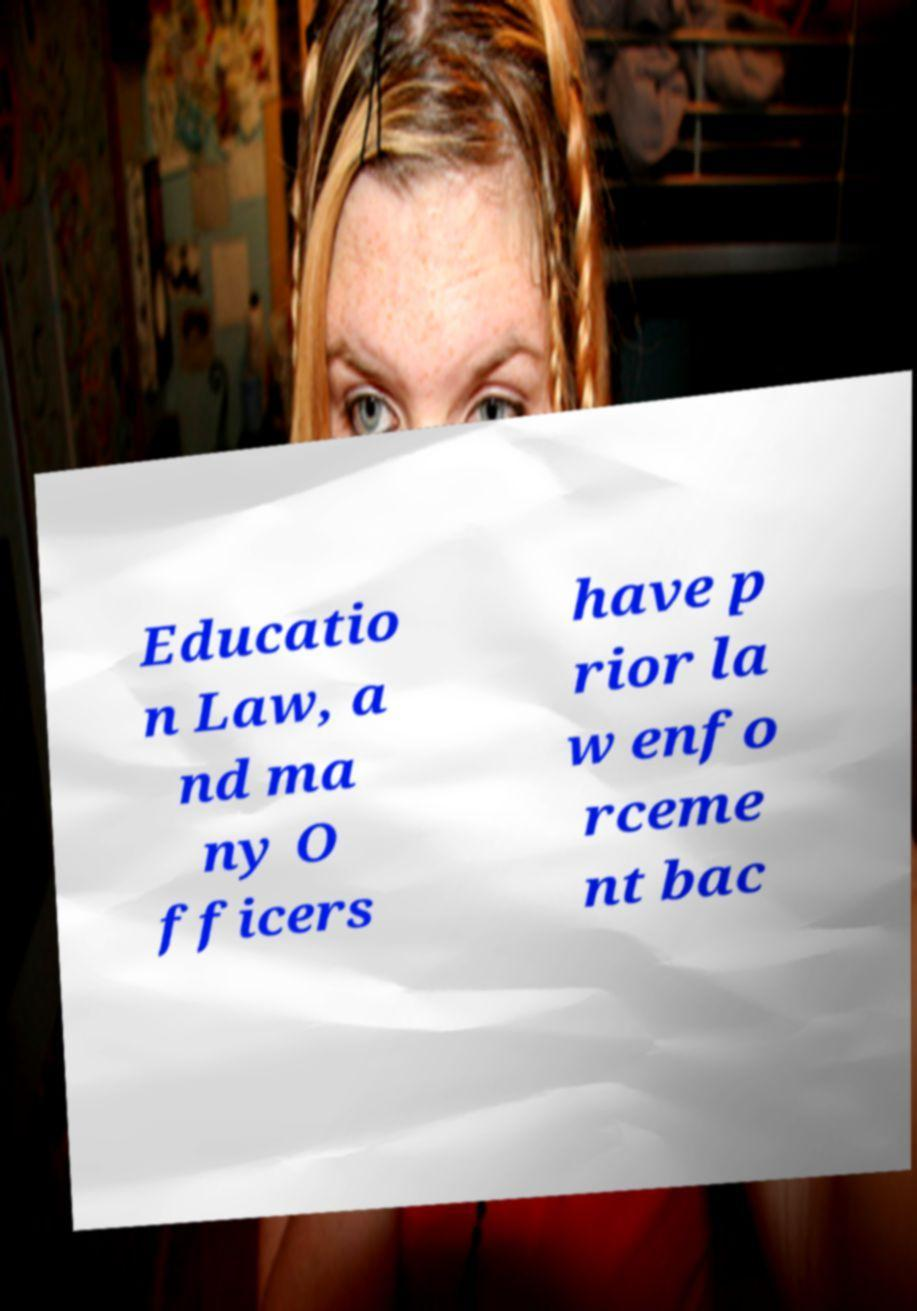Could you assist in decoding the text presented in this image and type it out clearly? Educatio n Law, a nd ma ny O fficers have p rior la w enfo rceme nt bac 